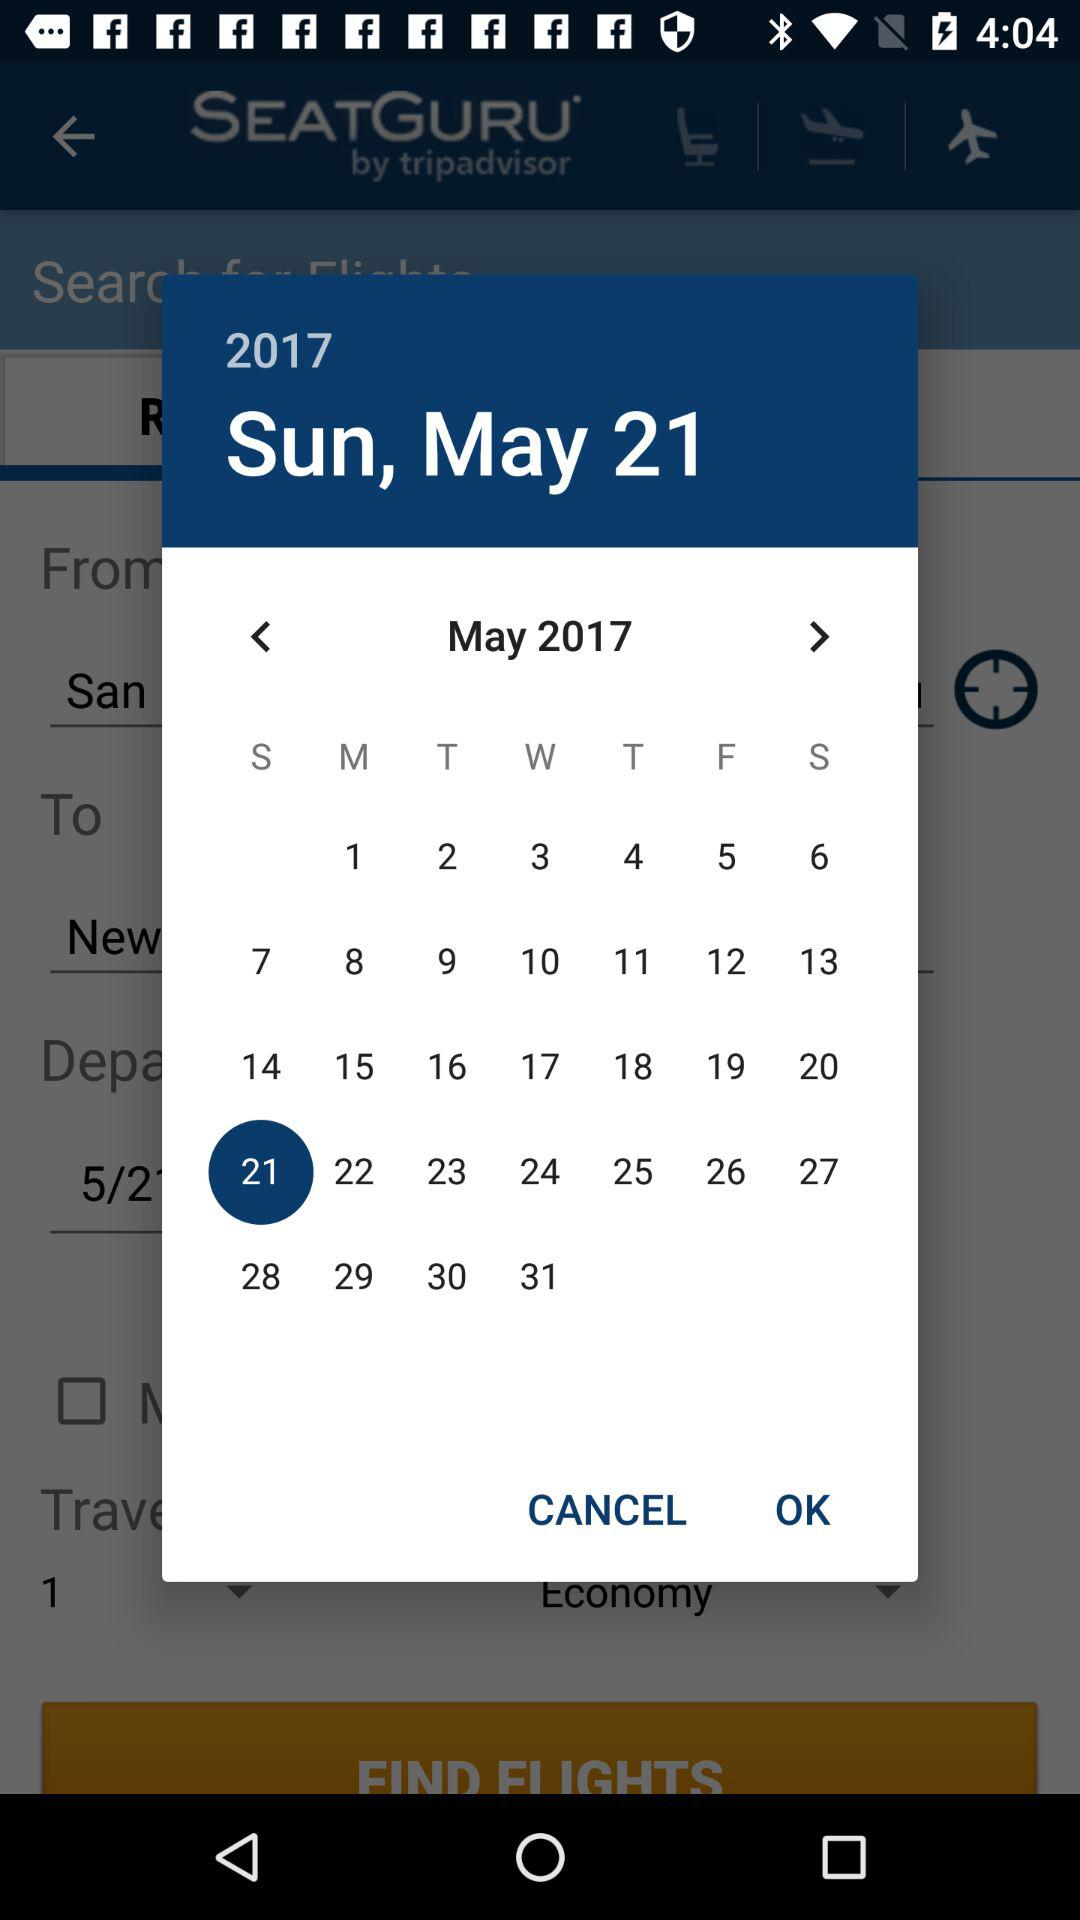What is the day on May 21, 2017? The day on May 21, 2017 is Sunday. 